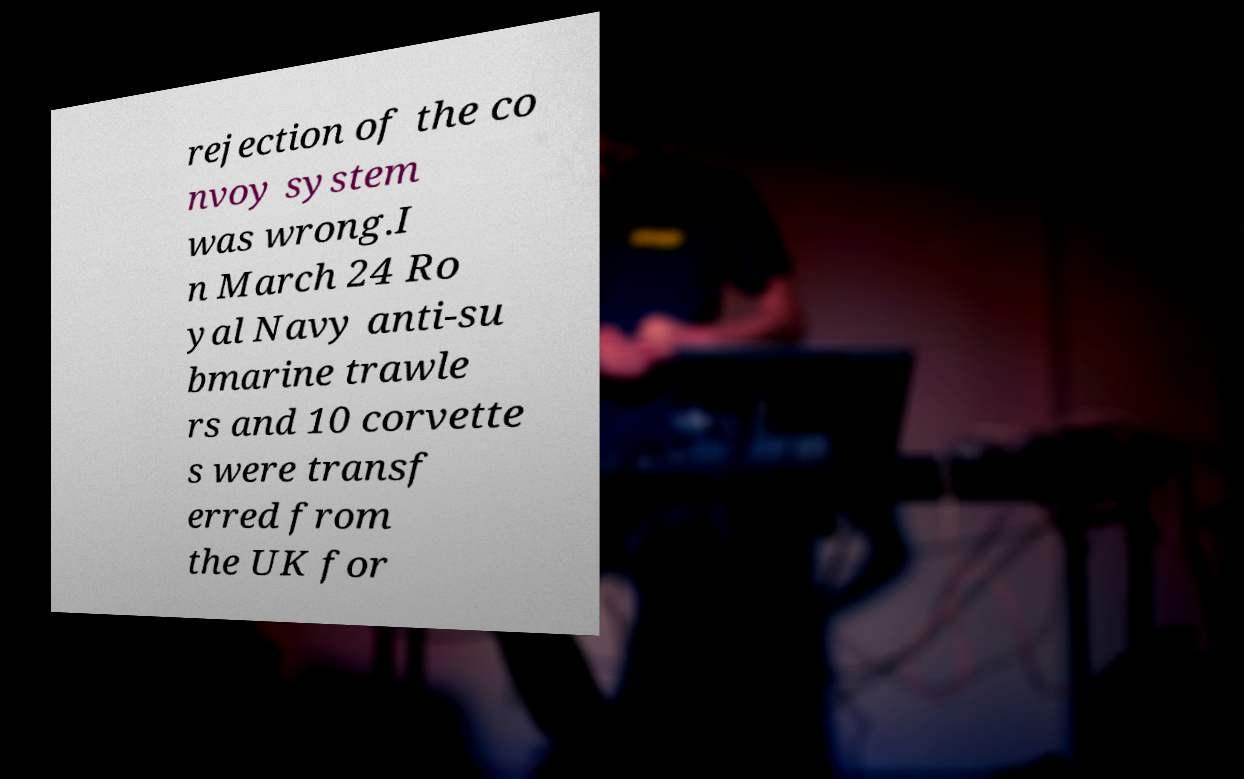Please read and relay the text visible in this image. What does it say? rejection of the co nvoy system was wrong.I n March 24 Ro yal Navy anti-su bmarine trawle rs and 10 corvette s were transf erred from the UK for 